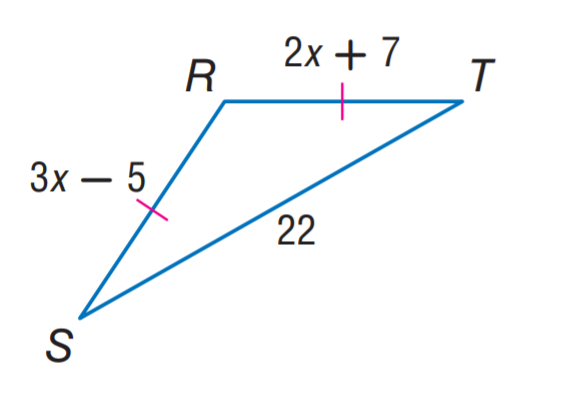Question: Find x.
Choices:
A. 7
B. 12
C. 22
D. 31
Answer with the letter. Answer: B Question: Find R T.
Choices:
A. 12
B. 22
C. 31
D. 33
Answer with the letter. Answer: C Question: Find R S.
Choices:
A. 12
B. 22
C. 31
D. 33
Answer with the letter. Answer: C 